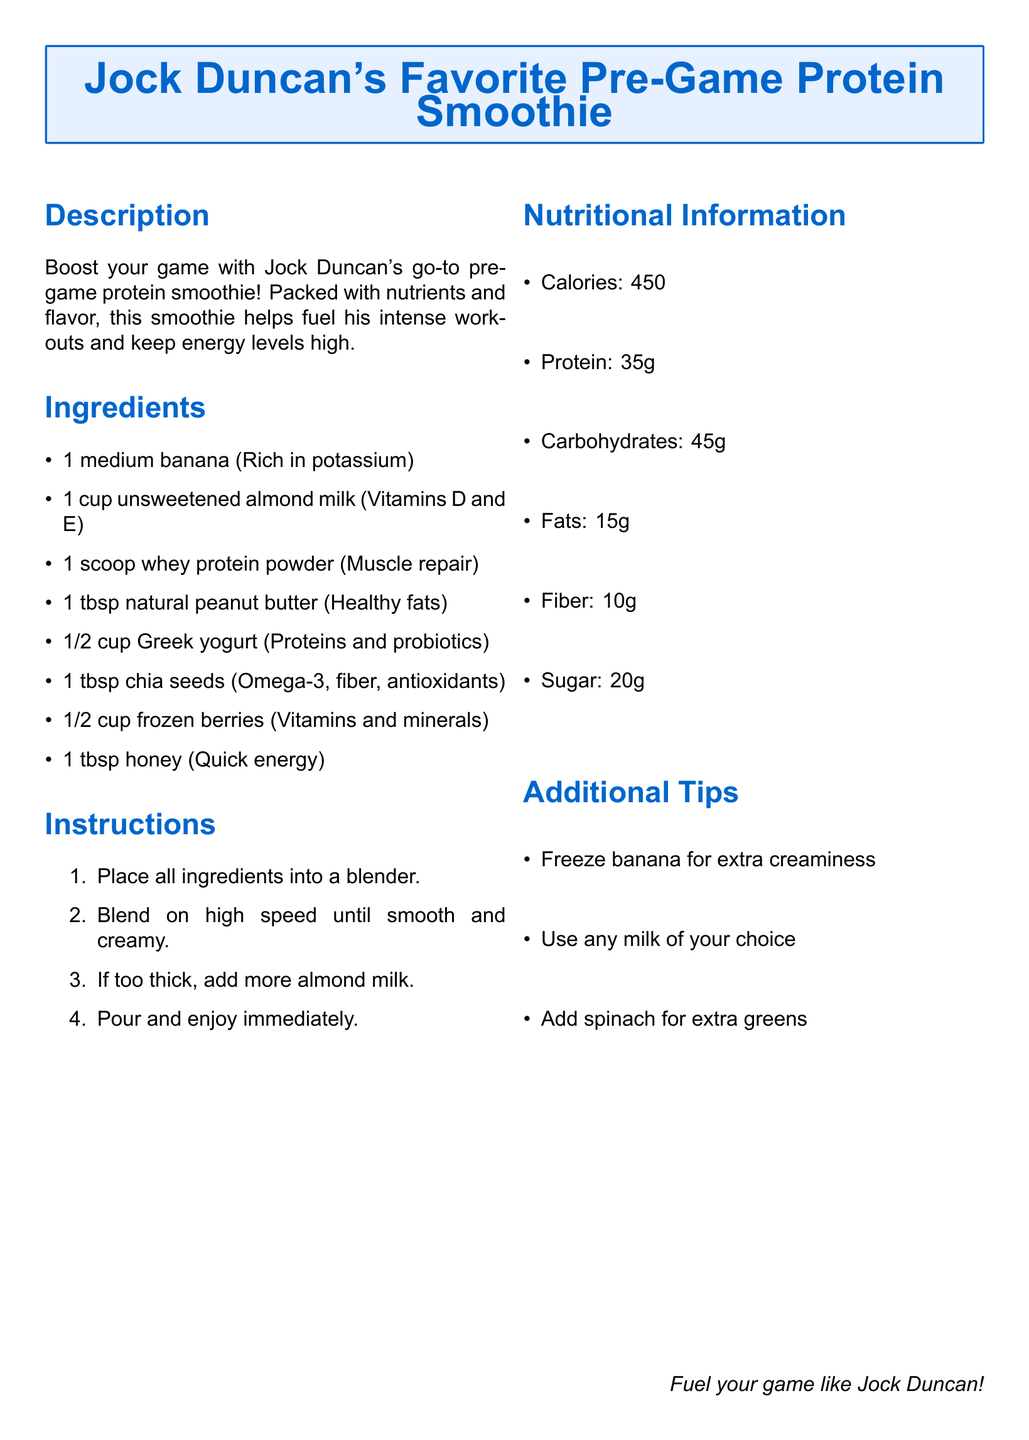What is the main purpose of the smoothie? The document describes the smoothie as boosting energy and helping fuel intense workouts, making it ideal for pre-game preparation.
Answer: Boost your game How many grams of protein does the smoothie contain? The nutritional section specifies the protein content listed under Nutritional Information.
Answer: 35g What type of milk is used in this recipe? The ingredient list explicitly states the type of milk to be used in the smoothie.
Answer: Unsweetened almond milk How many steps are there in the instructions? The instructions section contains a list that can be counted to determine the number of steps.
Answer: 4 What ingredient can be added for extra creaminess? The additional tips section mentions a way to enhance the smoothie’s texture.
Answer: Freeze banana What is the total calorie count for the smoothie? The nutritional information provides the total number of calories in the smoothie.
Answer: 450 What is the main source of protein in this smoothie? The ingredient list highlights the protein source used in the smoothie explicitly.
Answer: Whey protein powder Which ingredient is noted for providing quick energy? The ingredient list specifies which component contributes quick energy to the smoothie.
Answer: Honey 